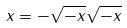<formula> <loc_0><loc_0><loc_500><loc_500>x = - \sqrt { - x } \sqrt { - x }</formula> 